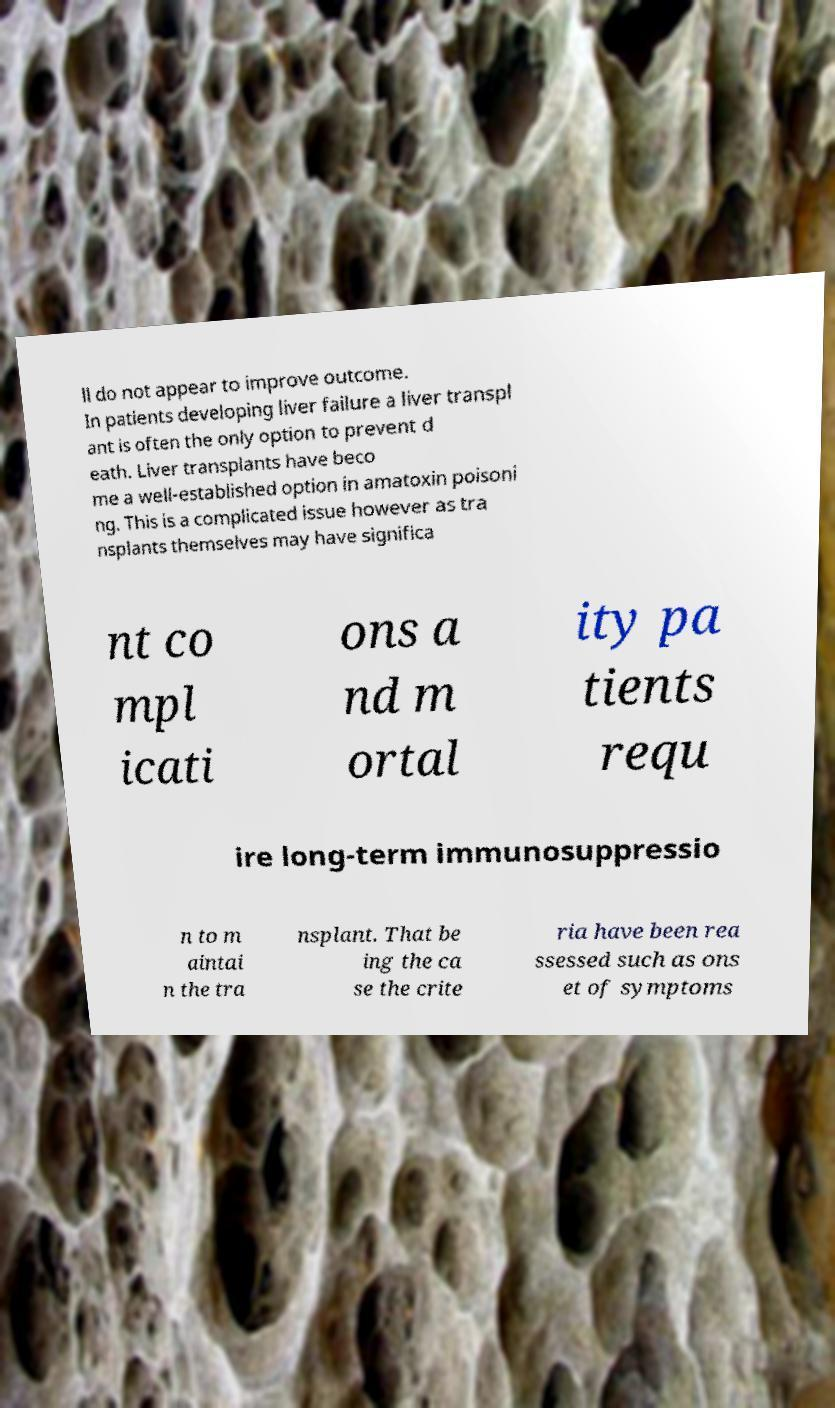There's text embedded in this image that I need extracted. Can you transcribe it verbatim? ll do not appear to improve outcome. In patients developing liver failure a liver transpl ant is often the only option to prevent d eath. Liver transplants have beco me a well-established option in amatoxin poisoni ng. This is a complicated issue however as tra nsplants themselves may have significa nt co mpl icati ons a nd m ortal ity pa tients requ ire long-term immunosuppressio n to m aintai n the tra nsplant. That be ing the ca se the crite ria have been rea ssessed such as ons et of symptoms 